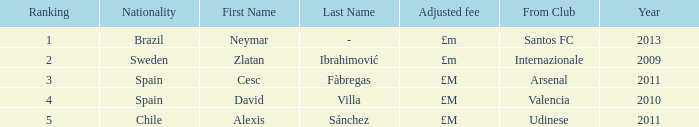Who is the spanish player with a ranking below 3? David Villa Category:Articles with hCards. 